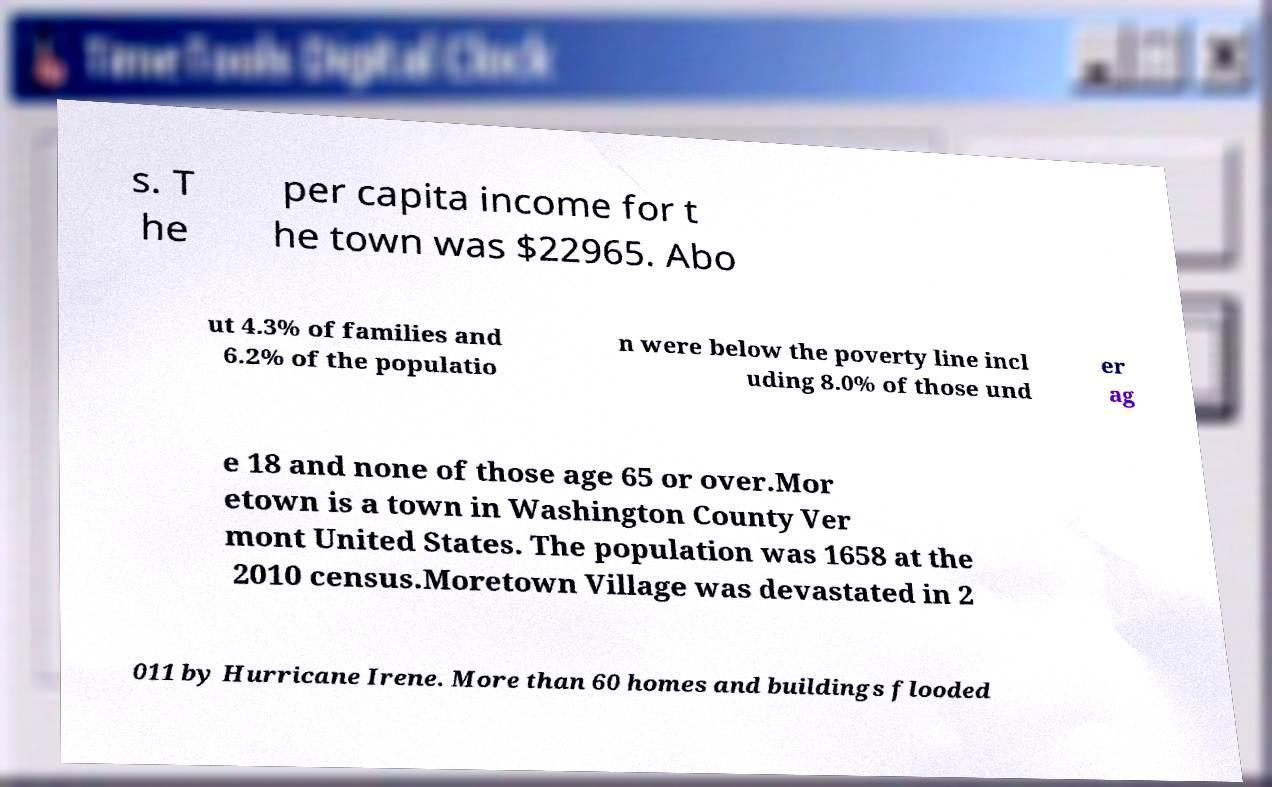Could you assist in decoding the text presented in this image and type it out clearly? s. T he per capita income for t he town was $22965. Abo ut 4.3% of families and 6.2% of the populatio n were below the poverty line incl uding 8.0% of those und er ag e 18 and none of those age 65 or over.Mor etown is a town in Washington County Ver mont United States. The population was 1658 at the 2010 census.Moretown Village was devastated in 2 011 by Hurricane Irene. More than 60 homes and buildings flooded 